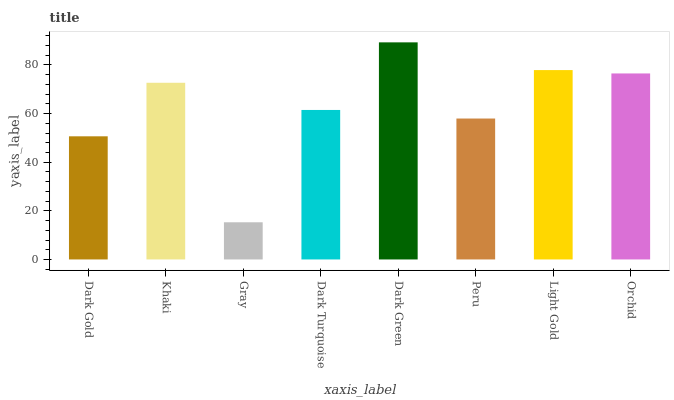Is Gray the minimum?
Answer yes or no. Yes. Is Dark Green the maximum?
Answer yes or no. Yes. Is Khaki the minimum?
Answer yes or no. No. Is Khaki the maximum?
Answer yes or no. No. Is Khaki greater than Dark Gold?
Answer yes or no. Yes. Is Dark Gold less than Khaki?
Answer yes or no. Yes. Is Dark Gold greater than Khaki?
Answer yes or no. No. Is Khaki less than Dark Gold?
Answer yes or no. No. Is Khaki the high median?
Answer yes or no. Yes. Is Dark Turquoise the low median?
Answer yes or no. Yes. Is Dark Gold the high median?
Answer yes or no. No. Is Gray the low median?
Answer yes or no. No. 